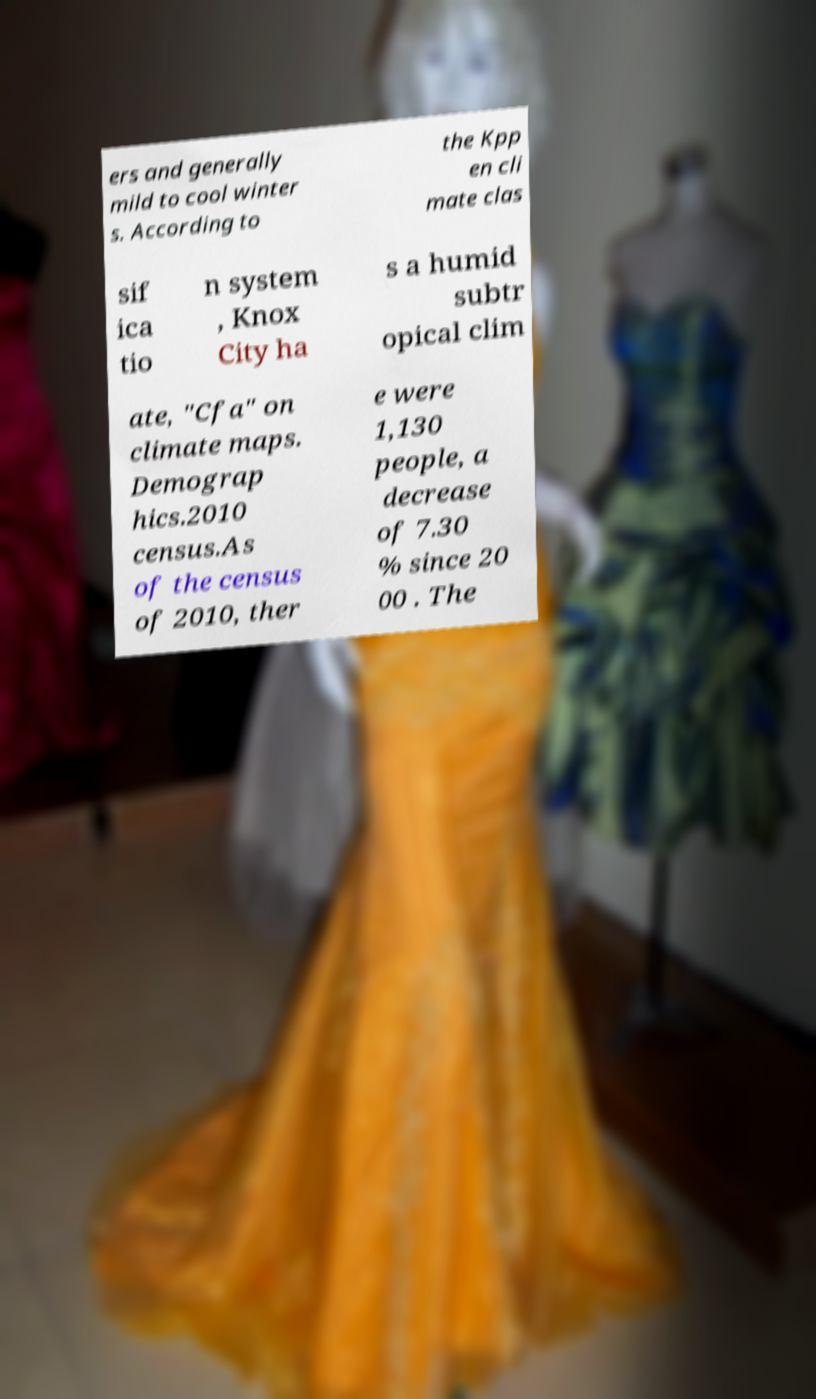Please identify and transcribe the text found in this image. ers and generally mild to cool winter s. According to the Kpp en cli mate clas sif ica tio n system , Knox City ha s a humid subtr opical clim ate, "Cfa" on climate maps. Demograp hics.2010 census.As of the census of 2010, ther e were 1,130 people, a decrease of 7.30 % since 20 00 . The 